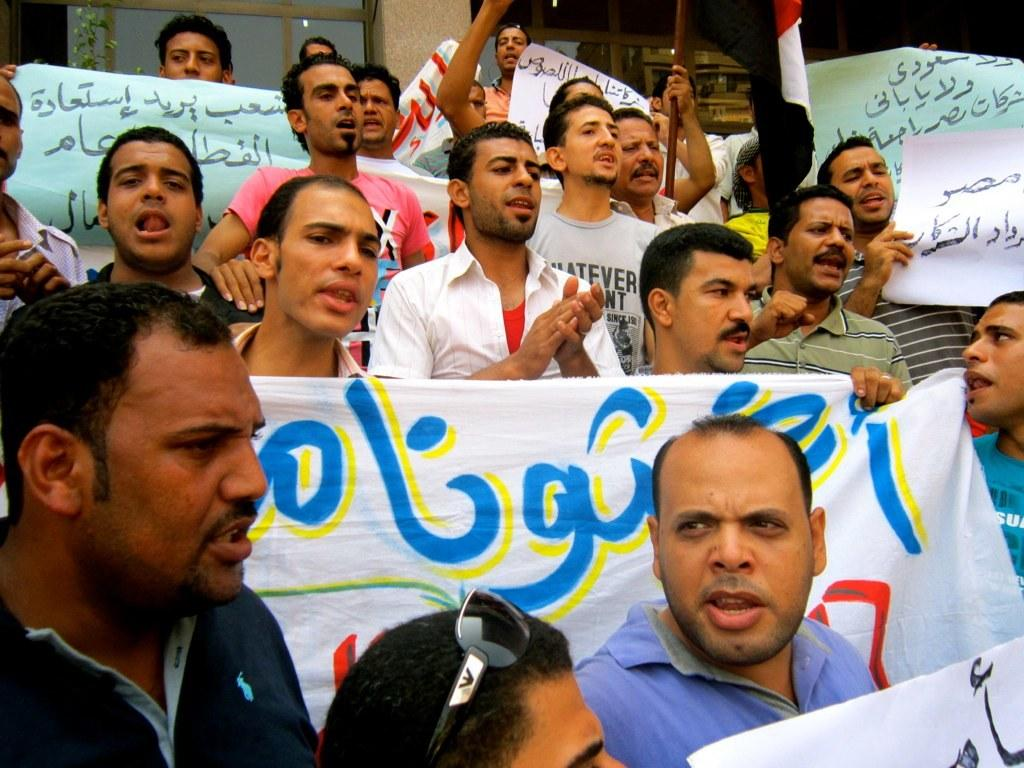What are the people in the image doing with the clothes? The people in the image are holding clothes. What is the man holding in the image? The man is holding a chart in the image. What can be seen on the backside of the image? There are windows and plants visible on the backside of the image. What type of shoe can be seen on the chart held by the man in the image? There is no shoe visible on the chart held by the man in the image. Is there a writer present in the image? There is no mention of a writer in the provided facts, and therefore we cannot confirm their presence in the image. 